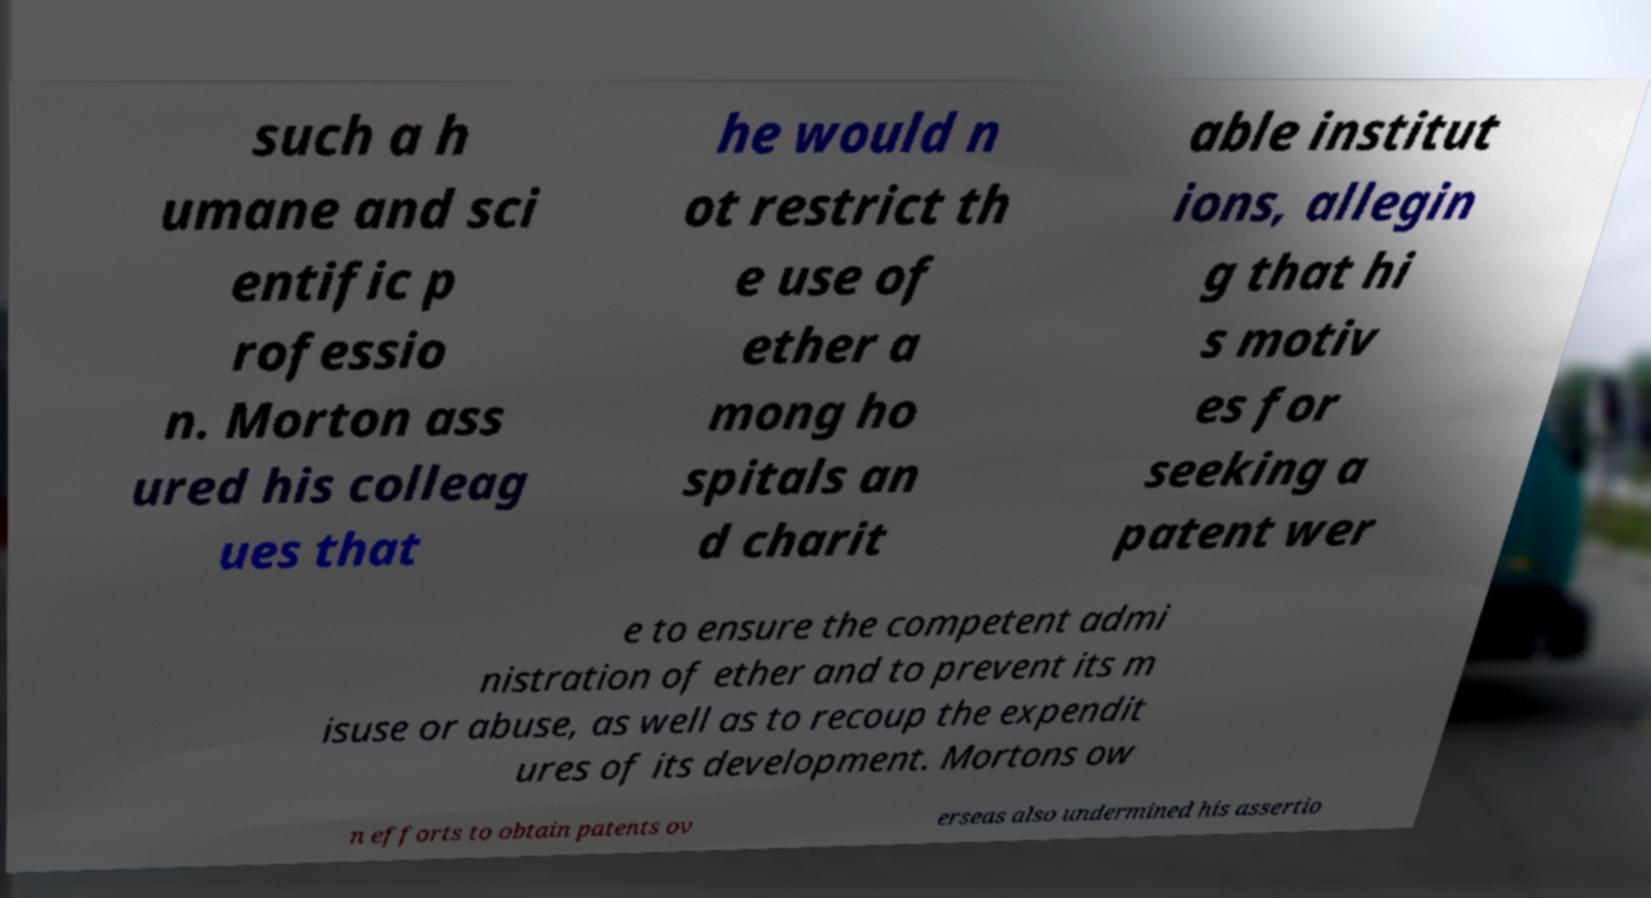Could you extract and type out the text from this image? such a h umane and sci entific p rofessio n. Morton ass ured his colleag ues that he would n ot restrict th e use of ether a mong ho spitals an d charit able institut ions, allegin g that hi s motiv es for seeking a patent wer e to ensure the competent admi nistration of ether and to prevent its m isuse or abuse, as well as to recoup the expendit ures of its development. Mortons ow n efforts to obtain patents ov erseas also undermined his assertio 